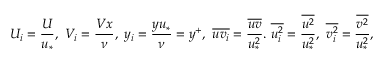Convert formula to latex. <formula><loc_0><loc_0><loc_500><loc_500>U _ { i } = \frac { U } { u _ { * } } , \ V _ { i } = \frac { V x } { \nu } , \ y _ { i } = \frac { y u _ { * } } { \nu } = y ^ { + } , \ \overline { { u v _ { i } } } = \frac { \overline { u v } } { u _ { * } ^ { 2 } } . \ \overline { { u _ { i } ^ { 2 } } } = \frac { \overline { { u ^ { 2 } } } } { u _ { * } ^ { 2 } } , \ \overline { { v _ { i } ^ { 2 } } } = \frac { \overline { { v ^ { 2 } } } } { u _ { * } ^ { 2 } } ,</formula> 